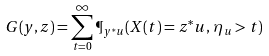Convert formula to latex. <formula><loc_0><loc_0><loc_500><loc_500>G ( y , z ) = \sum _ { t = 0 } ^ { \infty } \P _ { y ^ { * } u } ( X ( t ) = z ^ { * } u , \, \eta _ { u } > t )</formula> 